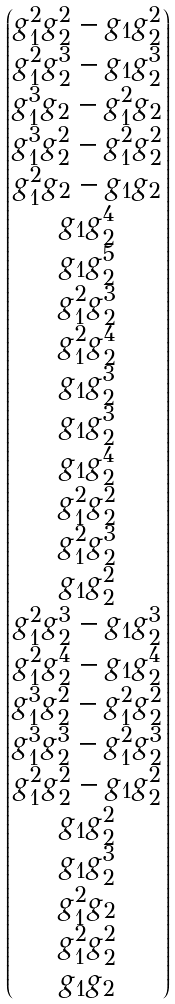<formula> <loc_0><loc_0><loc_500><loc_500>\begin{pmatrix} g _ { 1 } ^ { 2 } g _ { 2 } ^ { 2 } - g _ { 1 } g _ { 2 } ^ { 2 } \\ g _ { 1 } ^ { 2 } g _ { 2 } ^ { 3 } - g _ { 1 } g _ { 2 } ^ { 3 } \\ g _ { 1 } ^ { 3 } g _ { 2 } - g _ { 1 } ^ { 2 } g _ { 2 } \\ g _ { 1 } ^ { 3 } g _ { 2 } ^ { 2 } - g _ { 1 } ^ { 2 } g _ { 2 } ^ { 2 } \\ g _ { 1 } ^ { 2 } g _ { 2 } - g _ { 1 } g _ { 2 } \\ g _ { 1 } g _ { 2 } ^ { 4 } \\ g _ { 1 } g _ { 2 } ^ { 5 } \\ g _ { 1 } ^ { 2 } g _ { 2 } ^ { 3 } \\ g _ { 1 } ^ { 2 } g _ { 2 } ^ { 4 } \\ g _ { 1 } g _ { 2 } ^ { 3 } \\ g _ { 1 } g _ { 2 } ^ { 3 } \\ g _ { 1 } g _ { 2 } ^ { 4 } \\ g _ { 1 } ^ { 2 } g _ { 2 } ^ { 2 } \\ g _ { 1 } ^ { 2 } g _ { 2 } ^ { 3 } \\ g _ { 1 } g _ { 2 } ^ { 2 } \\ g _ { 1 } ^ { 2 } g _ { 2 } ^ { 3 } - g _ { 1 } g _ { 2 } ^ { 3 } \\ g _ { 1 } ^ { 2 } g _ { 2 } ^ { 4 } - g _ { 1 } g _ { 2 } ^ { 4 } \\ g _ { 1 } ^ { 3 } g _ { 2 } ^ { 2 } - g _ { 1 } ^ { 2 } g _ { 2 } ^ { 2 } \\ g _ { 1 } ^ { 3 } g _ { 2 } ^ { 3 } - g _ { 1 } ^ { 2 } g _ { 2 } ^ { 3 } \\ g _ { 1 } ^ { 2 } g _ { 2 } ^ { 2 } - g _ { 1 } g _ { 2 } ^ { 2 } \\ g _ { 1 } g _ { 2 } ^ { 2 } \\ g _ { 1 } g _ { 2 } ^ { 3 } \\ g _ { 1 } ^ { 2 } g _ { 2 } \\ g _ { 1 } ^ { 2 } g _ { 2 } ^ { 2 } \\ g _ { 1 } g _ { 2 } \\ \end{pmatrix}</formula> 